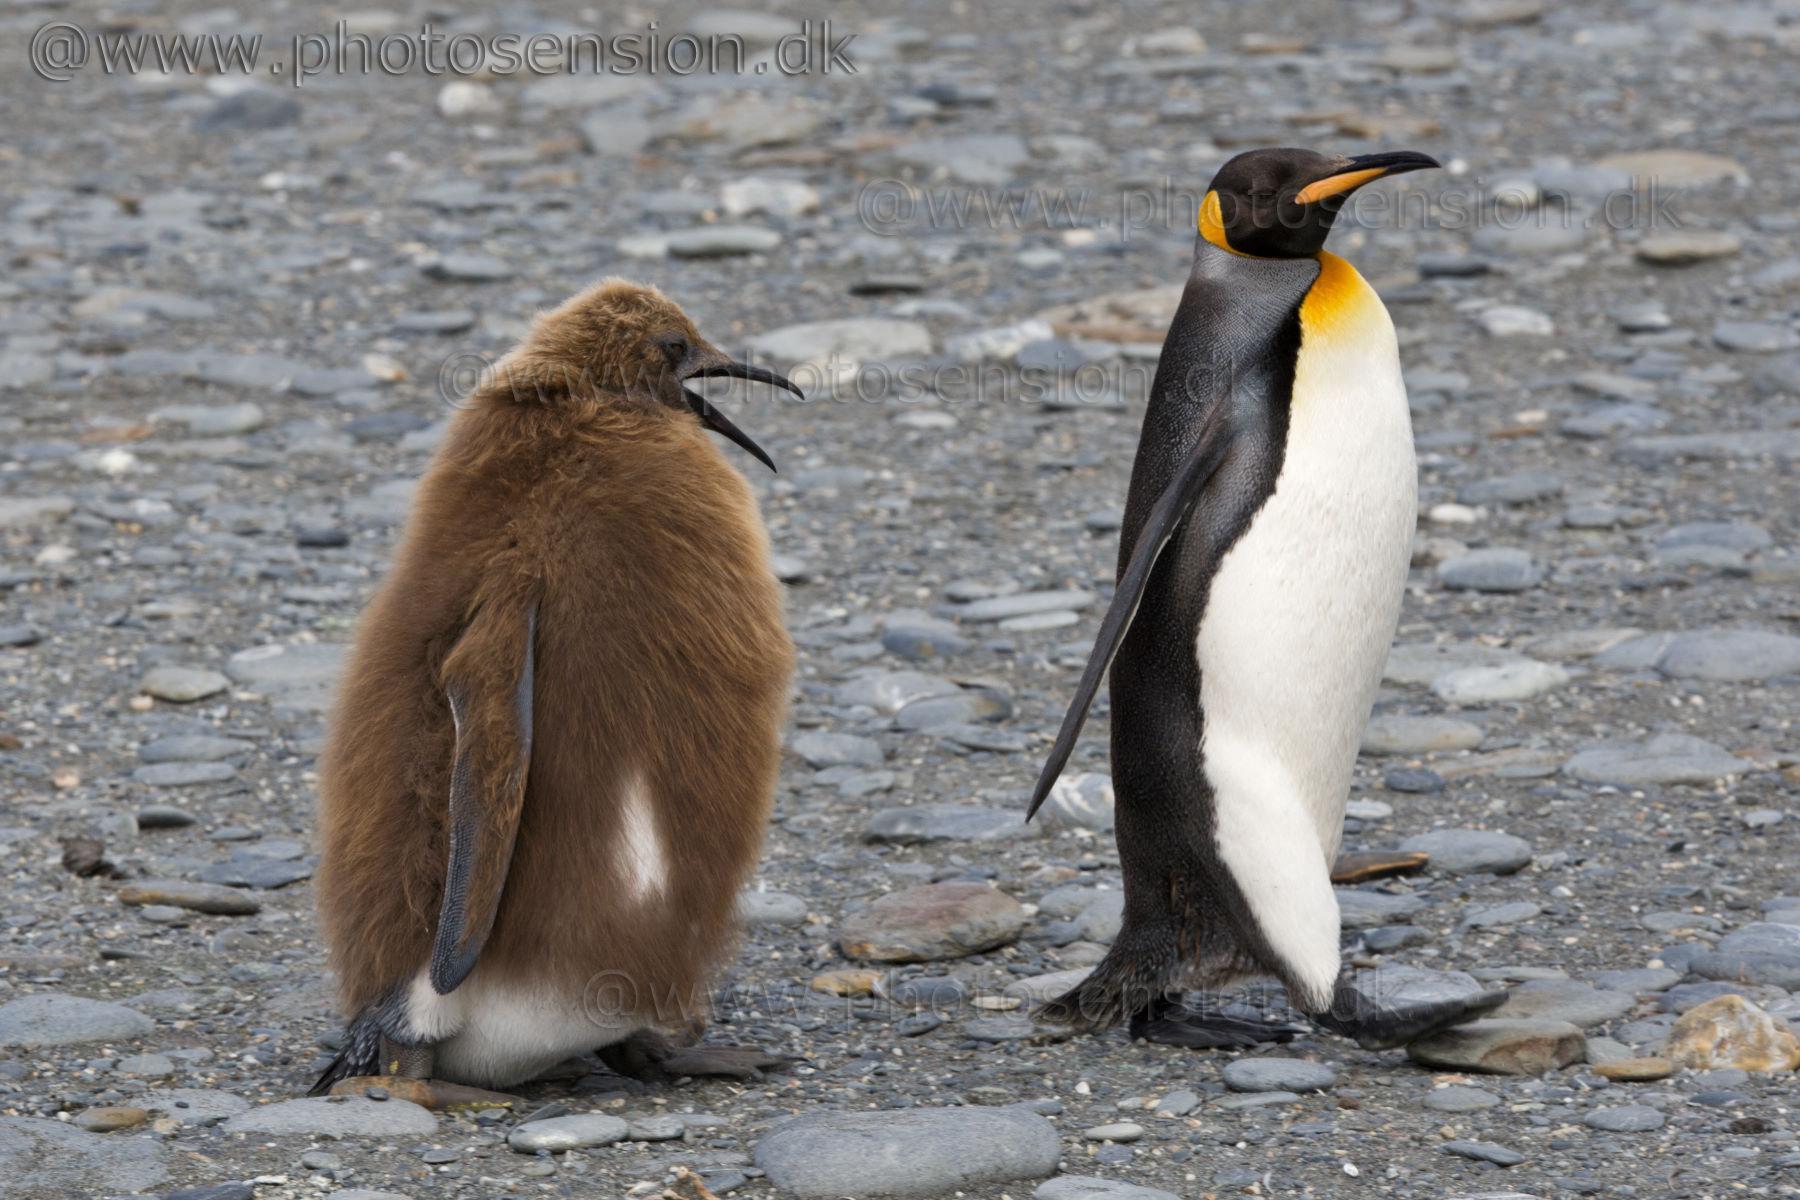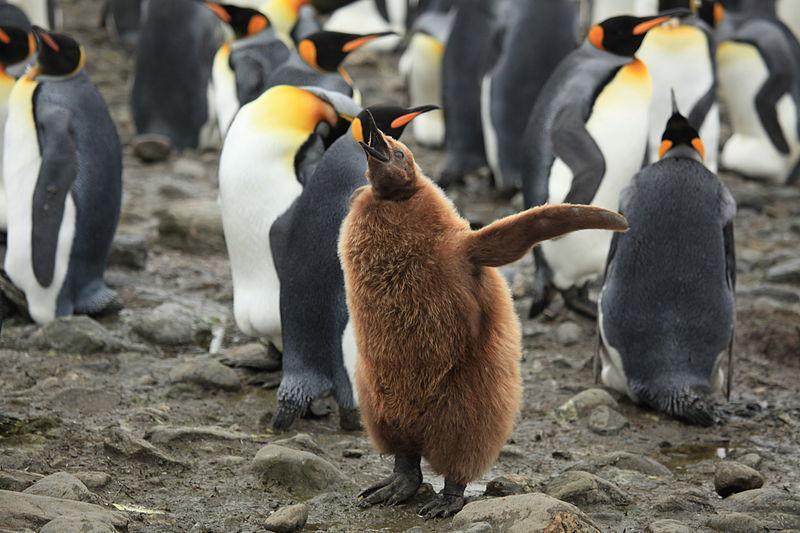The first image is the image on the left, the second image is the image on the right. For the images displayed, is the sentence "There are no more than three penguins standing on the ground." factually correct? Answer yes or no. No. 